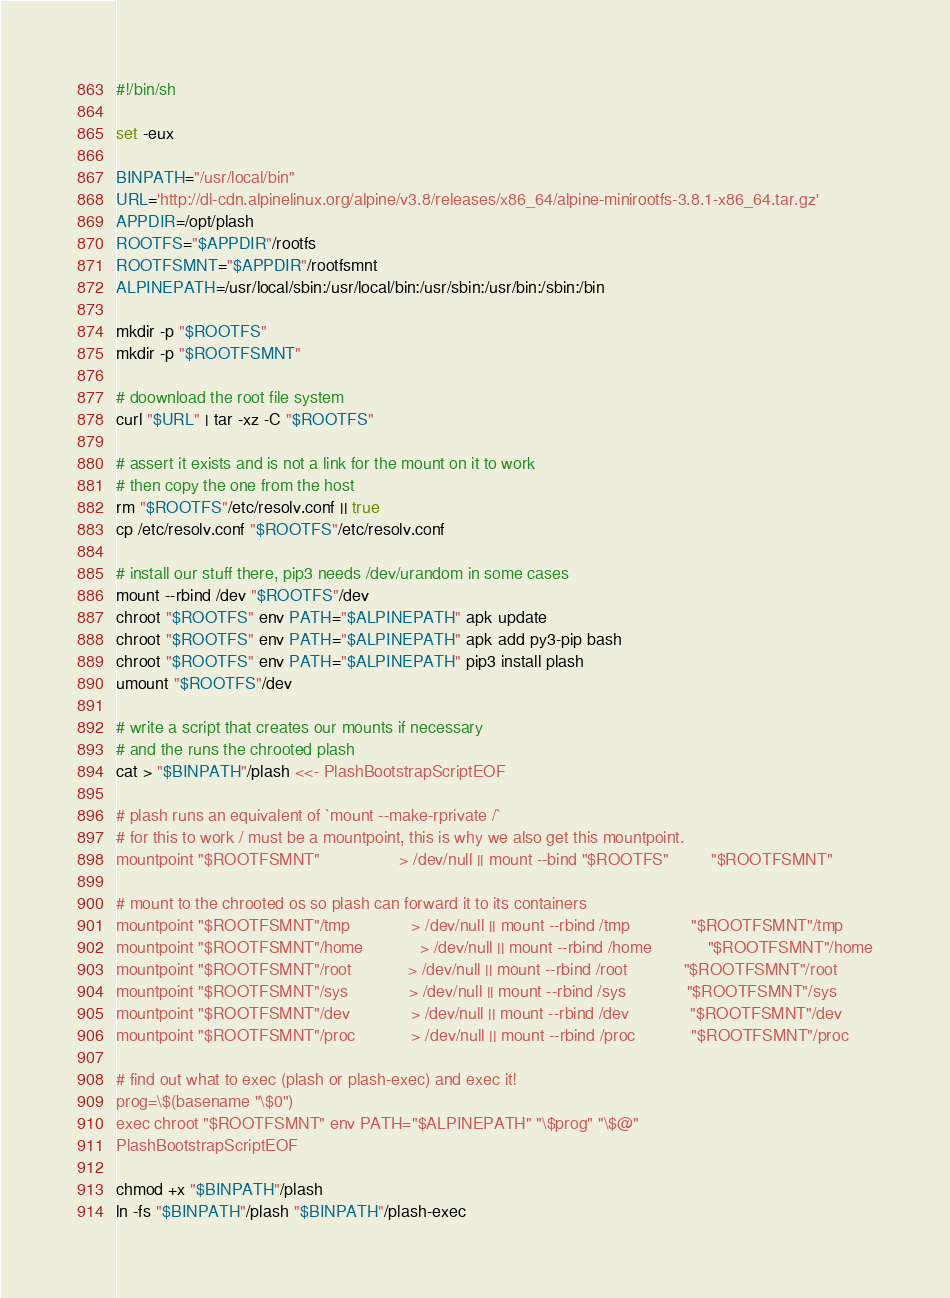Convert code to text. <code><loc_0><loc_0><loc_500><loc_500><_Bash_>#!/bin/sh

set -eux

BINPATH="/usr/local/bin"
URL='http://dl-cdn.alpinelinux.org/alpine/v3.8/releases/x86_64/alpine-minirootfs-3.8.1-x86_64.tar.gz'
APPDIR=/opt/plash
ROOTFS="$APPDIR"/rootfs
ROOTFSMNT="$APPDIR"/rootfsmnt
ALPINEPATH=/usr/local/sbin:/usr/local/bin:/usr/sbin:/usr/bin:/sbin:/bin

mkdir -p "$ROOTFS"
mkdir -p "$ROOTFSMNT"

# doownload the root file system
curl "$URL" | tar -xz -C "$ROOTFS"

# assert it exists and is not a link for the mount on it to work
# then copy the one from the host
rm "$ROOTFS"/etc/resolv.conf || true
cp /etc/resolv.conf "$ROOTFS"/etc/resolv.conf
    
# install our stuff there, pip3 needs /dev/urandom in some cases
mount --rbind /dev "$ROOTFS"/dev
chroot "$ROOTFS" env PATH="$ALPINEPATH" apk update
chroot "$ROOTFS" env PATH="$ALPINEPATH" apk add py3-pip bash
chroot "$ROOTFS" env PATH="$ALPINEPATH" pip3 install plash
umount "$ROOTFS"/dev

# write a script that creates our mounts if necessary
# and the runs the chrooted plash
cat > "$BINPATH"/plash <<- PlashBootstrapScriptEOF

# plash runs an equivalent of `mount --make-rprivate /`
# for this to work / must be a mountpoint, this is why we also get this mountpoint.
mountpoint "$ROOTFSMNT"                 > /dev/null || mount --bind "$ROOTFS"         "$ROOTFSMNT"

# mount to the chrooted os so plash can forward it to its containers
mountpoint "$ROOTFSMNT"/tmp             > /dev/null || mount --rbind /tmp             "$ROOTFSMNT"/tmp
mountpoint "$ROOTFSMNT"/home            > /dev/null || mount --rbind /home            "$ROOTFSMNT"/home
mountpoint "$ROOTFSMNT"/root            > /dev/null || mount --rbind /root            "$ROOTFSMNT"/root
mountpoint "$ROOTFSMNT"/sys             > /dev/null || mount --rbind /sys             "$ROOTFSMNT"/sys
mountpoint "$ROOTFSMNT"/dev             > /dev/null || mount --rbind /dev             "$ROOTFSMNT"/dev
mountpoint "$ROOTFSMNT"/proc            > /dev/null || mount --rbind /proc            "$ROOTFSMNT"/proc

# find out what to exec (plash or plash-exec) and exec it!
prog=\$(basename "\$0")
exec chroot "$ROOTFSMNT" env PATH="$ALPINEPATH" "\$prog" "\$@"
PlashBootstrapScriptEOF

chmod +x "$BINPATH"/plash
ln -fs "$BINPATH"/plash "$BINPATH"/plash-exec
</code> 